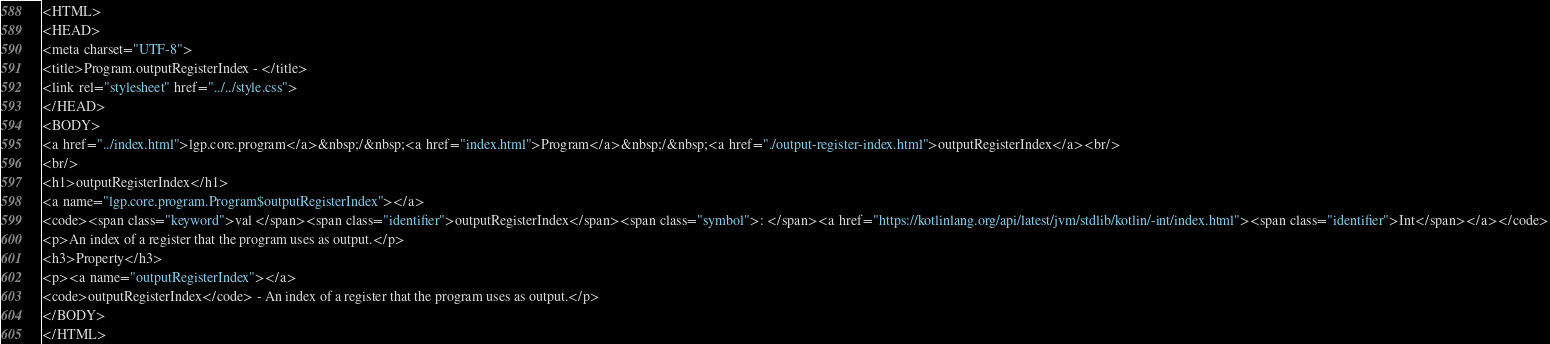Convert code to text. <code><loc_0><loc_0><loc_500><loc_500><_HTML_><HTML>
<HEAD>
<meta charset="UTF-8">
<title>Program.outputRegisterIndex - </title>
<link rel="stylesheet" href="../../style.css">
</HEAD>
<BODY>
<a href="../index.html">lgp.core.program</a>&nbsp;/&nbsp;<a href="index.html">Program</a>&nbsp;/&nbsp;<a href="./output-register-index.html">outputRegisterIndex</a><br/>
<br/>
<h1>outputRegisterIndex</h1>
<a name="lgp.core.program.Program$outputRegisterIndex"></a>
<code><span class="keyword">val </span><span class="identifier">outputRegisterIndex</span><span class="symbol">: </span><a href="https://kotlinlang.org/api/latest/jvm/stdlib/kotlin/-int/index.html"><span class="identifier">Int</span></a></code>
<p>An index of a register that the program uses as output.</p>
<h3>Property</h3>
<p><a name="outputRegisterIndex"></a>
<code>outputRegisterIndex</code> - An index of a register that the program uses as output.</p>
</BODY>
</HTML>
</code> 